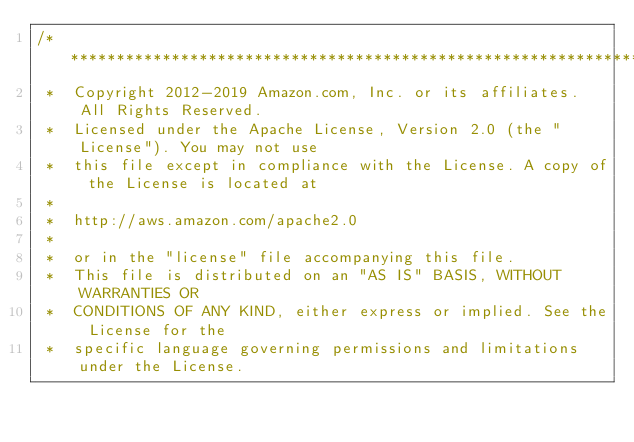Convert code to text. <code><loc_0><loc_0><loc_500><loc_500><_C#_>/*******************************************************************************
 *  Copyright 2012-2019 Amazon.com, Inc. or its affiliates. All Rights Reserved.
 *  Licensed under the Apache License, Version 2.0 (the "License"). You may not use
 *  this file except in compliance with the License. A copy of the License is located at
 *
 *  http://aws.amazon.com/apache2.0
 *
 *  or in the "license" file accompanying this file.
 *  This file is distributed on an "AS IS" BASIS, WITHOUT WARRANTIES OR
 *  CONDITIONS OF ANY KIND, either express or implied. See the License for the
 *  specific language governing permissions and limitations under the License.</code> 